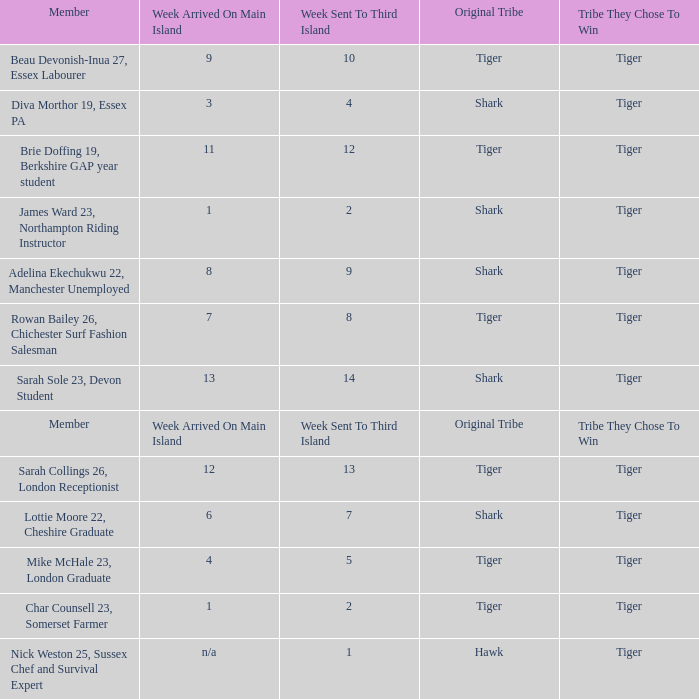Who was sent to the third island in week 1? Nick Weston 25, Sussex Chef and Survival Expert. 